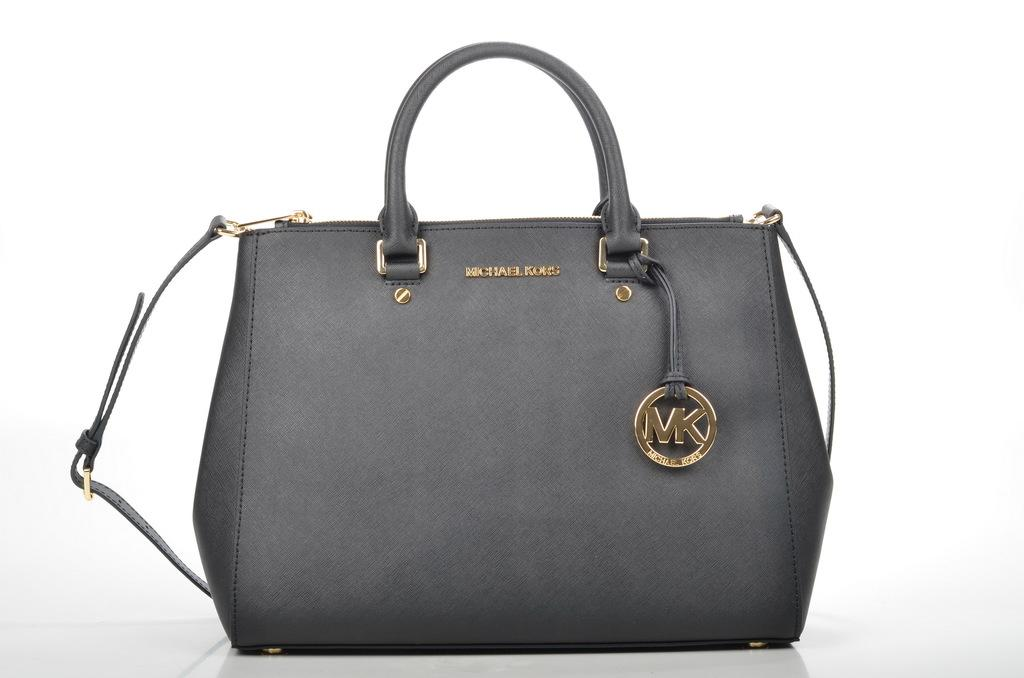What type of accessory is visible in the image? There is a black handbag in the image. Where is the handbag located? The handbag is on the floor. What color is the background of the image? The background of the image is white. Where was the image taken? The image was taken inside a room. How many dimes are visible on the floor next to the handbag in the image? There are no dimes visible in the image; only the black handbag is present. 